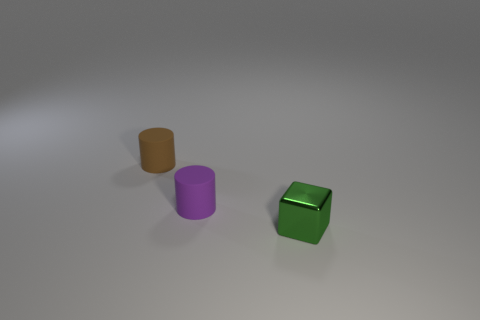This seems to be a minimalist composition; what might be the purpose of such a design? A minimalist composition like this often serves to emphasize form and color. It can be used in various contexts, such as visual arts to invoke contemplation or in product design to focus on the functionality and aesthetic of objects without distraction. 